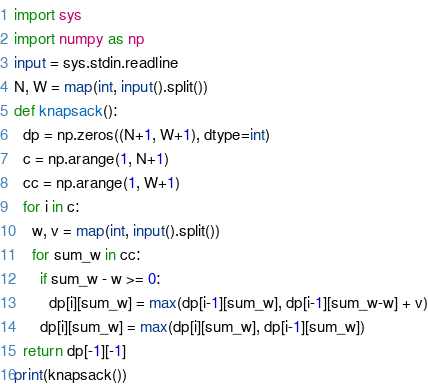<code> <loc_0><loc_0><loc_500><loc_500><_Python_>import sys
import numpy as np
input = sys.stdin.readline
N, W = map(int, input().split())
def knapsack():
  dp = np.zeros((N+1, W+1), dtype=int)
  c = np.arange(1, N+1)
  cc = np.arange(1, W+1)
  for i in c:
    w, v = map(int, input().split())
    for sum_w in cc:
      if sum_w - w >= 0:
        dp[i][sum_w] = max(dp[i-1][sum_w], dp[i-1][sum_w-w] + v)
      dp[i][sum_w] = max(dp[i][sum_w], dp[i-1][sum_w])
  return dp[-1][-1]
print(knapsack())</code> 